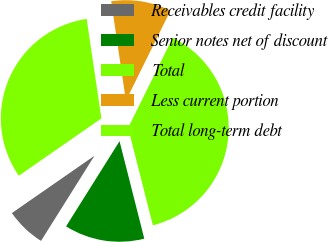Convert chart to OTSL. <chart><loc_0><loc_0><loc_500><loc_500><pie_chart><fcel>Receivables credit facility<fcel>Senior notes net of discount<fcel>Total<fcel>Less current portion<fcel>Total long-term debt<nl><fcel>6.42%<fcel>12.88%<fcel>38.74%<fcel>9.65%<fcel>32.32%<nl></chart> 